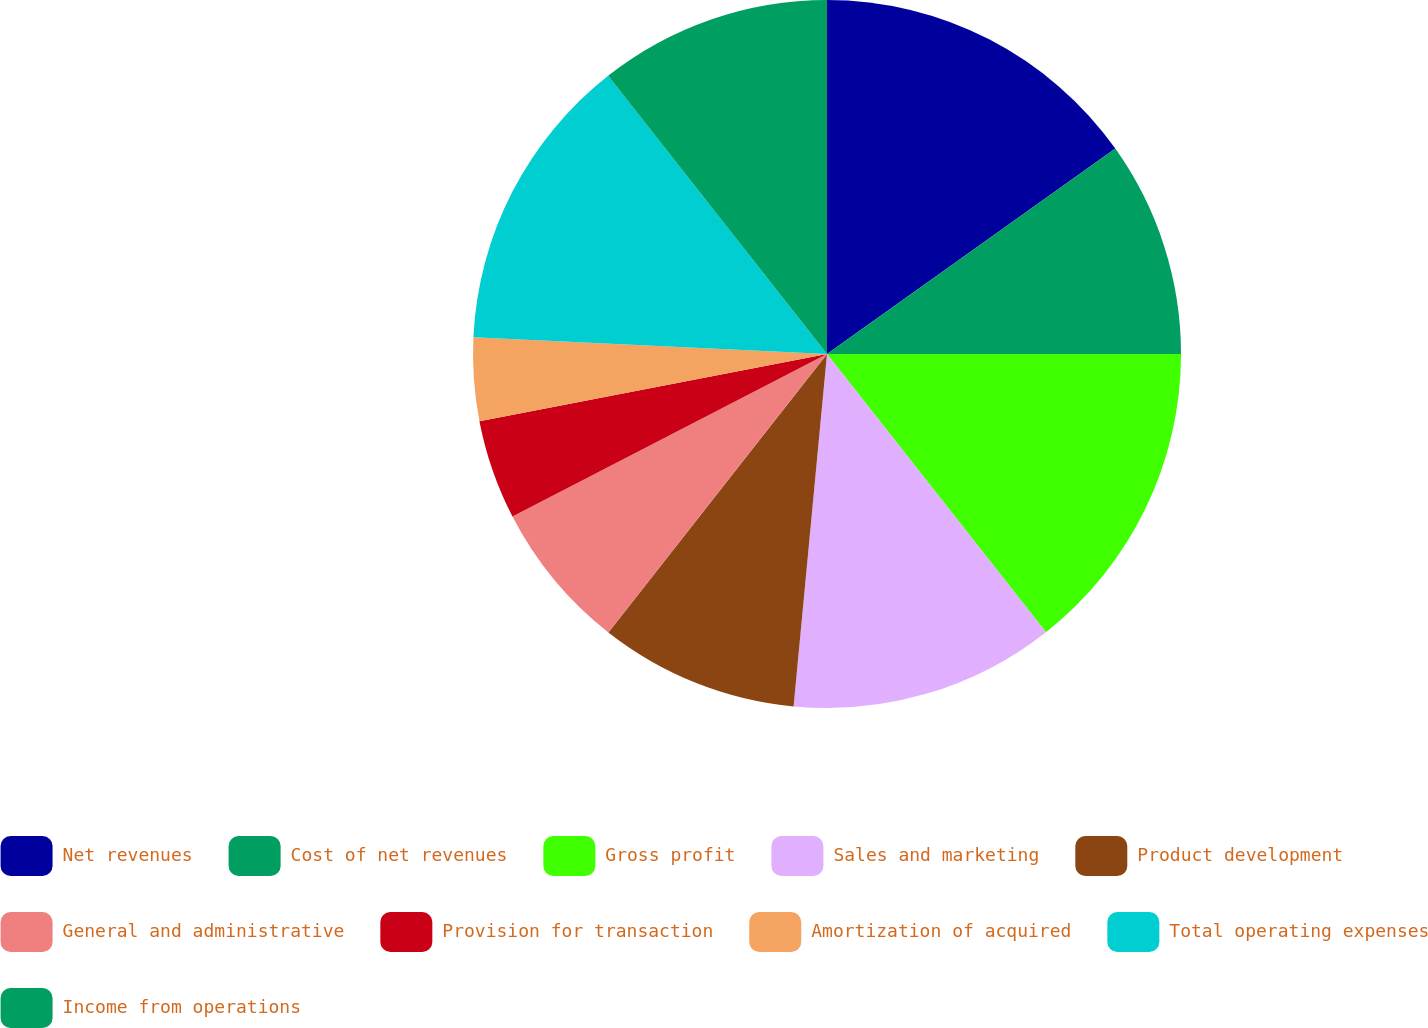<chart> <loc_0><loc_0><loc_500><loc_500><pie_chart><fcel>Net revenues<fcel>Cost of net revenues<fcel>Gross profit<fcel>Sales and marketing<fcel>Product development<fcel>General and administrative<fcel>Provision for transaction<fcel>Amortization of acquired<fcel>Total operating expenses<fcel>Income from operations<nl><fcel>15.15%<fcel>9.85%<fcel>14.39%<fcel>12.12%<fcel>9.09%<fcel>6.82%<fcel>4.55%<fcel>3.79%<fcel>13.64%<fcel>10.61%<nl></chart> 